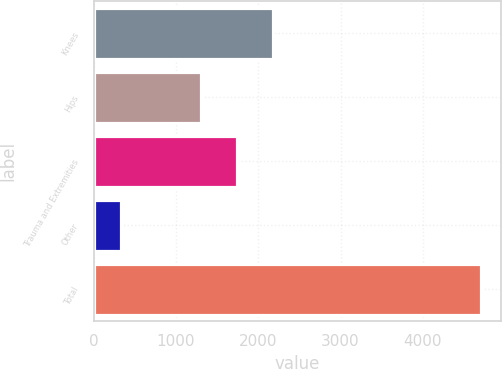Convert chart to OTSL. <chart><loc_0><loc_0><loc_500><loc_500><bar_chart><fcel>Knees<fcel>Hips<fcel>Trauma and Extremities<fcel>Other<fcel>Total<nl><fcel>2178.2<fcel>1303<fcel>1740.6<fcel>337<fcel>4713<nl></chart> 